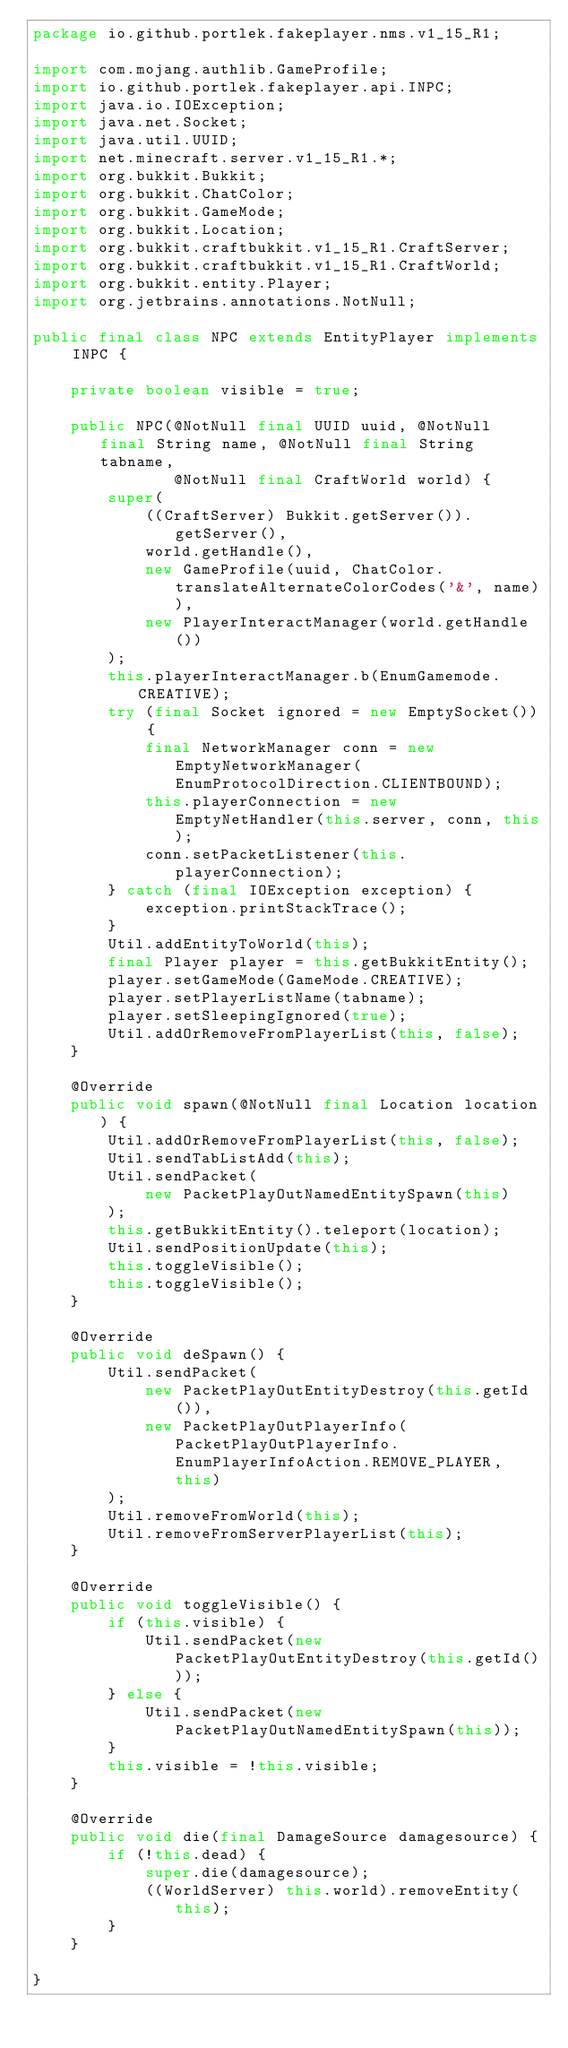<code> <loc_0><loc_0><loc_500><loc_500><_Java_>package io.github.portlek.fakeplayer.nms.v1_15_R1;

import com.mojang.authlib.GameProfile;
import io.github.portlek.fakeplayer.api.INPC;
import java.io.IOException;
import java.net.Socket;
import java.util.UUID;
import net.minecraft.server.v1_15_R1.*;
import org.bukkit.Bukkit;
import org.bukkit.ChatColor;
import org.bukkit.GameMode;
import org.bukkit.Location;
import org.bukkit.craftbukkit.v1_15_R1.CraftServer;
import org.bukkit.craftbukkit.v1_15_R1.CraftWorld;
import org.bukkit.entity.Player;
import org.jetbrains.annotations.NotNull;

public final class NPC extends EntityPlayer implements INPC {

    private boolean visible = true;

    public NPC(@NotNull final UUID uuid, @NotNull final String name, @NotNull final String tabname,
               @NotNull final CraftWorld world) {
        super(
            ((CraftServer) Bukkit.getServer()).getServer(),
            world.getHandle(),
            new GameProfile(uuid, ChatColor.translateAlternateColorCodes('&', name)),
            new PlayerInteractManager(world.getHandle())
        );
        this.playerInteractManager.b(EnumGamemode.CREATIVE);
        try (final Socket ignored = new EmptySocket()) {
            final NetworkManager conn = new EmptyNetworkManager(EnumProtocolDirection.CLIENTBOUND);
            this.playerConnection = new EmptyNetHandler(this.server, conn, this);
            conn.setPacketListener(this.playerConnection);
        } catch (final IOException exception) {
            exception.printStackTrace();
        }
        Util.addEntityToWorld(this);
        final Player player = this.getBukkitEntity();
        player.setGameMode(GameMode.CREATIVE);
        player.setPlayerListName(tabname);
        player.setSleepingIgnored(true);
        Util.addOrRemoveFromPlayerList(this, false);
    }

    @Override
    public void spawn(@NotNull final Location location) {
        Util.addOrRemoveFromPlayerList(this, false);
        Util.sendTabListAdd(this);
        Util.sendPacket(
            new PacketPlayOutNamedEntitySpawn(this)
        );
        this.getBukkitEntity().teleport(location);
        Util.sendPositionUpdate(this);
        this.toggleVisible();
        this.toggleVisible();
    }

    @Override
    public void deSpawn() {
        Util.sendPacket(
            new PacketPlayOutEntityDestroy(this.getId()),
            new PacketPlayOutPlayerInfo(PacketPlayOutPlayerInfo.EnumPlayerInfoAction.REMOVE_PLAYER, this)
        );
        Util.removeFromWorld(this);
        Util.removeFromServerPlayerList(this);
    }

    @Override
    public void toggleVisible() {
        if (this.visible) {
            Util.sendPacket(new PacketPlayOutEntityDestroy(this.getId()));
        } else {
            Util.sendPacket(new PacketPlayOutNamedEntitySpawn(this));
        }
        this.visible = !this.visible;
    }

    @Override
    public void die(final DamageSource damagesource) {
        if (!this.dead) {
            super.die(damagesource);
            ((WorldServer) this.world).removeEntity(this);
        }
    }

}
</code> 